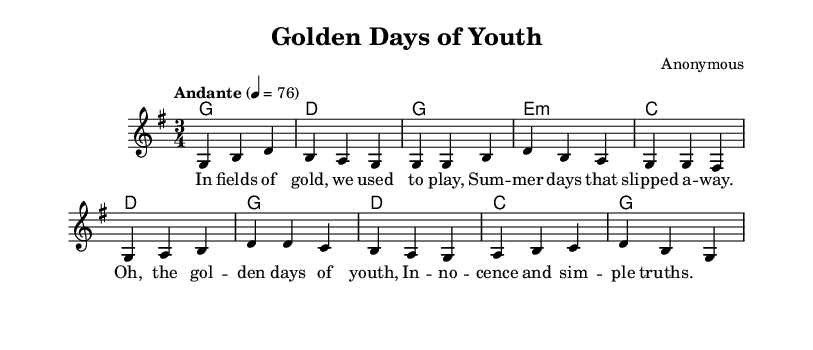What is the key signature of this music? The key signature is G major, which contains one sharp (F#). This is identified by the presence of the F# in the key signature section of the music sheet.
Answer: G major What is the time signature of this music? The time signature is 3/4, which indicates that there are three beats in each measure and the quarter note gets one beat. This can be found at the beginning of the score.
Answer: 3/4 What is the tempo marking for this piece? The tempo marking is "Andante," which suggests a moderate walking pace. This is indicated in the tempo section at the start of the music.
Answer: Andante How many measures are in the introduction of the music? The introduction consists of two measures, as indicated by the two lines in the melody section at the beginning of the score.
Answer: 2 What are the first four notes of the melody? The first four notes of the melody are G, B, D, and B. These can be found in the melody line of the score, where the notes are clearly notated.
Answer: G B D B What is the chord progression in the verse? The chord progression in the verse is G, E minor, C, D. This can be deduced by looking at the harmonies indicated above the melody line during the verse section.
Answer: G E minor C D What themes does the lyrics of this piece explore? The lyrics reflect themes of childhood nostalgia and innocence, as indicated by phrases such as "fields of gold" and "golden days of youth." This thematic content is evident from reading the lyrics provided in the sheet music.
Answer: Nostalgia and innocence 